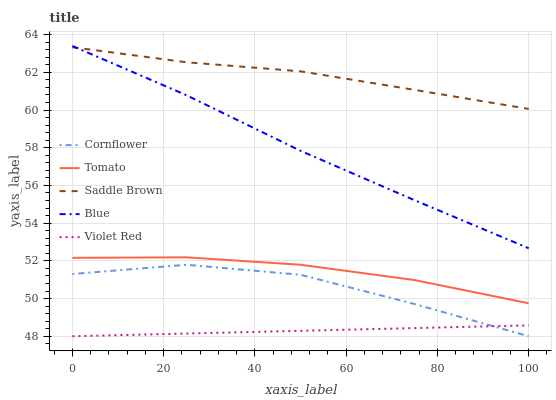Does Cornflower have the minimum area under the curve?
Answer yes or no. No. Does Cornflower have the maximum area under the curve?
Answer yes or no. No. Is Cornflower the smoothest?
Answer yes or no. No. Is Violet Red the roughest?
Answer yes or no. No. Does Saddle Brown have the lowest value?
Answer yes or no. No. Does Cornflower have the highest value?
Answer yes or no. No. Is Tomato less than Saddle Brown?
Answer yes or no. Yes. Is Tomato greater than Cornflower?
Answer yes or no. Yes. Does Tomato intersect Saddle Brown?
Answer yes or no. No. 